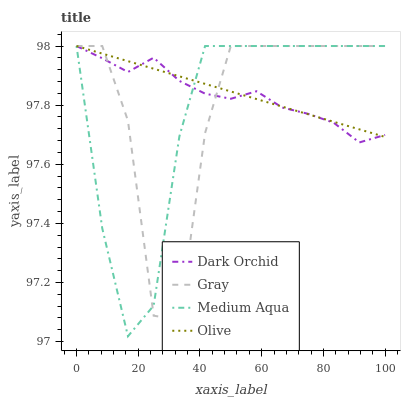Does Medium Aqua have the minimum area under the curve?
Answer yes or no. Yes. Does Olive have the maximum area under the curve?
Answer yes or no. Yes. Does Gray have the minimum area under the curve?
Answer yes or no. No. Does Gray have the maximum area under the curve?
Answer yes or no. No. Is Olive the smoothest?
Answer yes or no. Yes. Is Gray the roughest?
Answer yes or no. Yes. Is Medium Aqua the smoothest?
Answer yes or no. No. Is Medium Aqua the roughest?
Answer yes or no. No. Does Medium Aqua have the lowest value?
Answer yes or no. Yes. Does Gray have the lowest value?
Answer yes or no. No. Does Dark Orchid have the highest value?
Answer yes or no. Yes. Does Dark Orchid intersect Gray?
Answer yes or no. Yes. Is Dark Orchid less than Gray?
Answer yes or no. No. Is Dark Orchid greater than Gray?
Answer yes or no. No. 